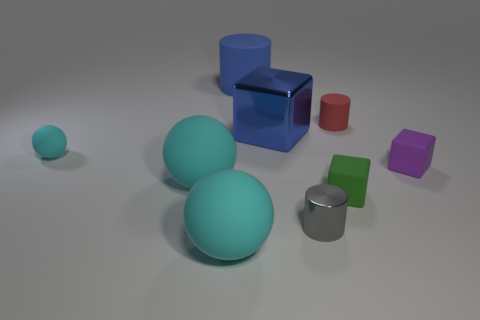Subtract all big blue rubber cylinders. How many cylinders are left? 2 Subtract all cubes. How many objects are left? 6 Subtract 2 cylinders. How many cylinders are left? 1 Subtract 0 green cylinders. How many objects are left? 9 Subtract all purple cylinders. Subtract all yellow balls. How many cylinders are left? 3 Subtract all big cyan metallic things. Subtract all matte cubes. How many objects are left? 7 Add 2 green objects. How many green objects are left? 3 Add 1 blue metal blocks. How many blue metal blocks exist? 2 Subtract all gray cylinders. How many cylinders are left? 2 